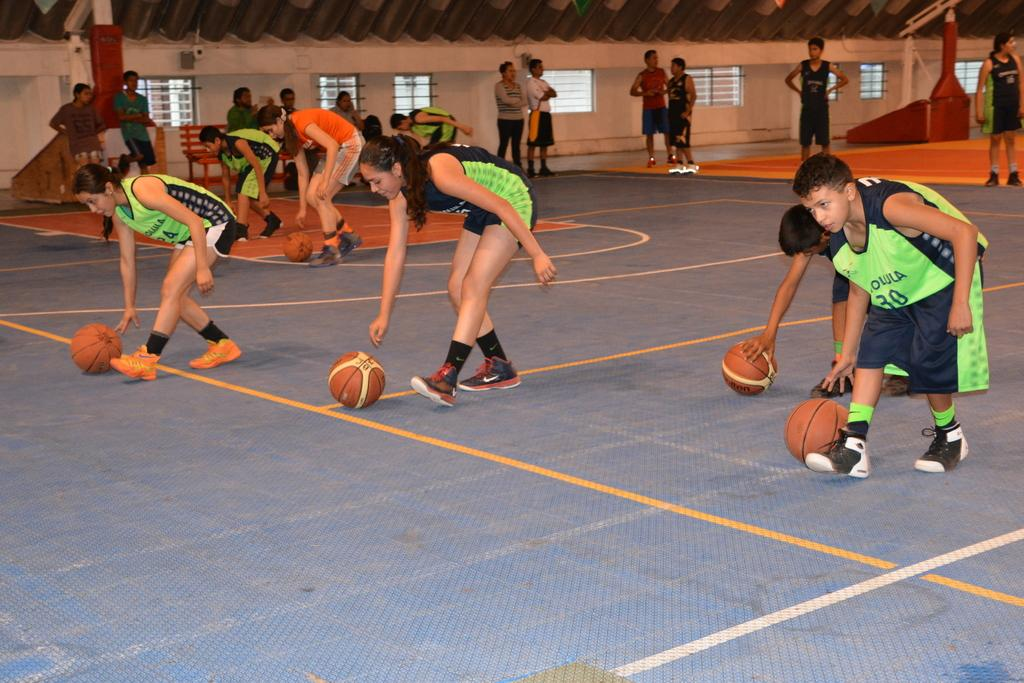What are the people in the image doing together? The people in the image are standing together and holding a ball on the floor. Can you describe the other group of people in the image? There is another group of people standing under a tent in the image. What type of house is visible in the image? There is no house visible in the image. Is there a water fountain in the image? There is no water fountain mentioned or visible in the image. 